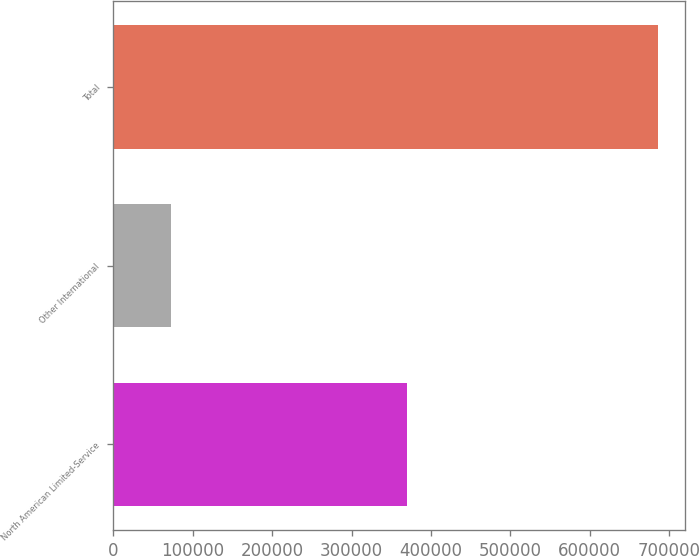Convert chart. <chart><loc_0><loc_0><loc_500><loc_500><bar_chart><fcel>North American Limited-Service<fcel>Other International<fcel>Total<nl><fcel>369347<fcel>72866<fcel>685365<nl></chart> 